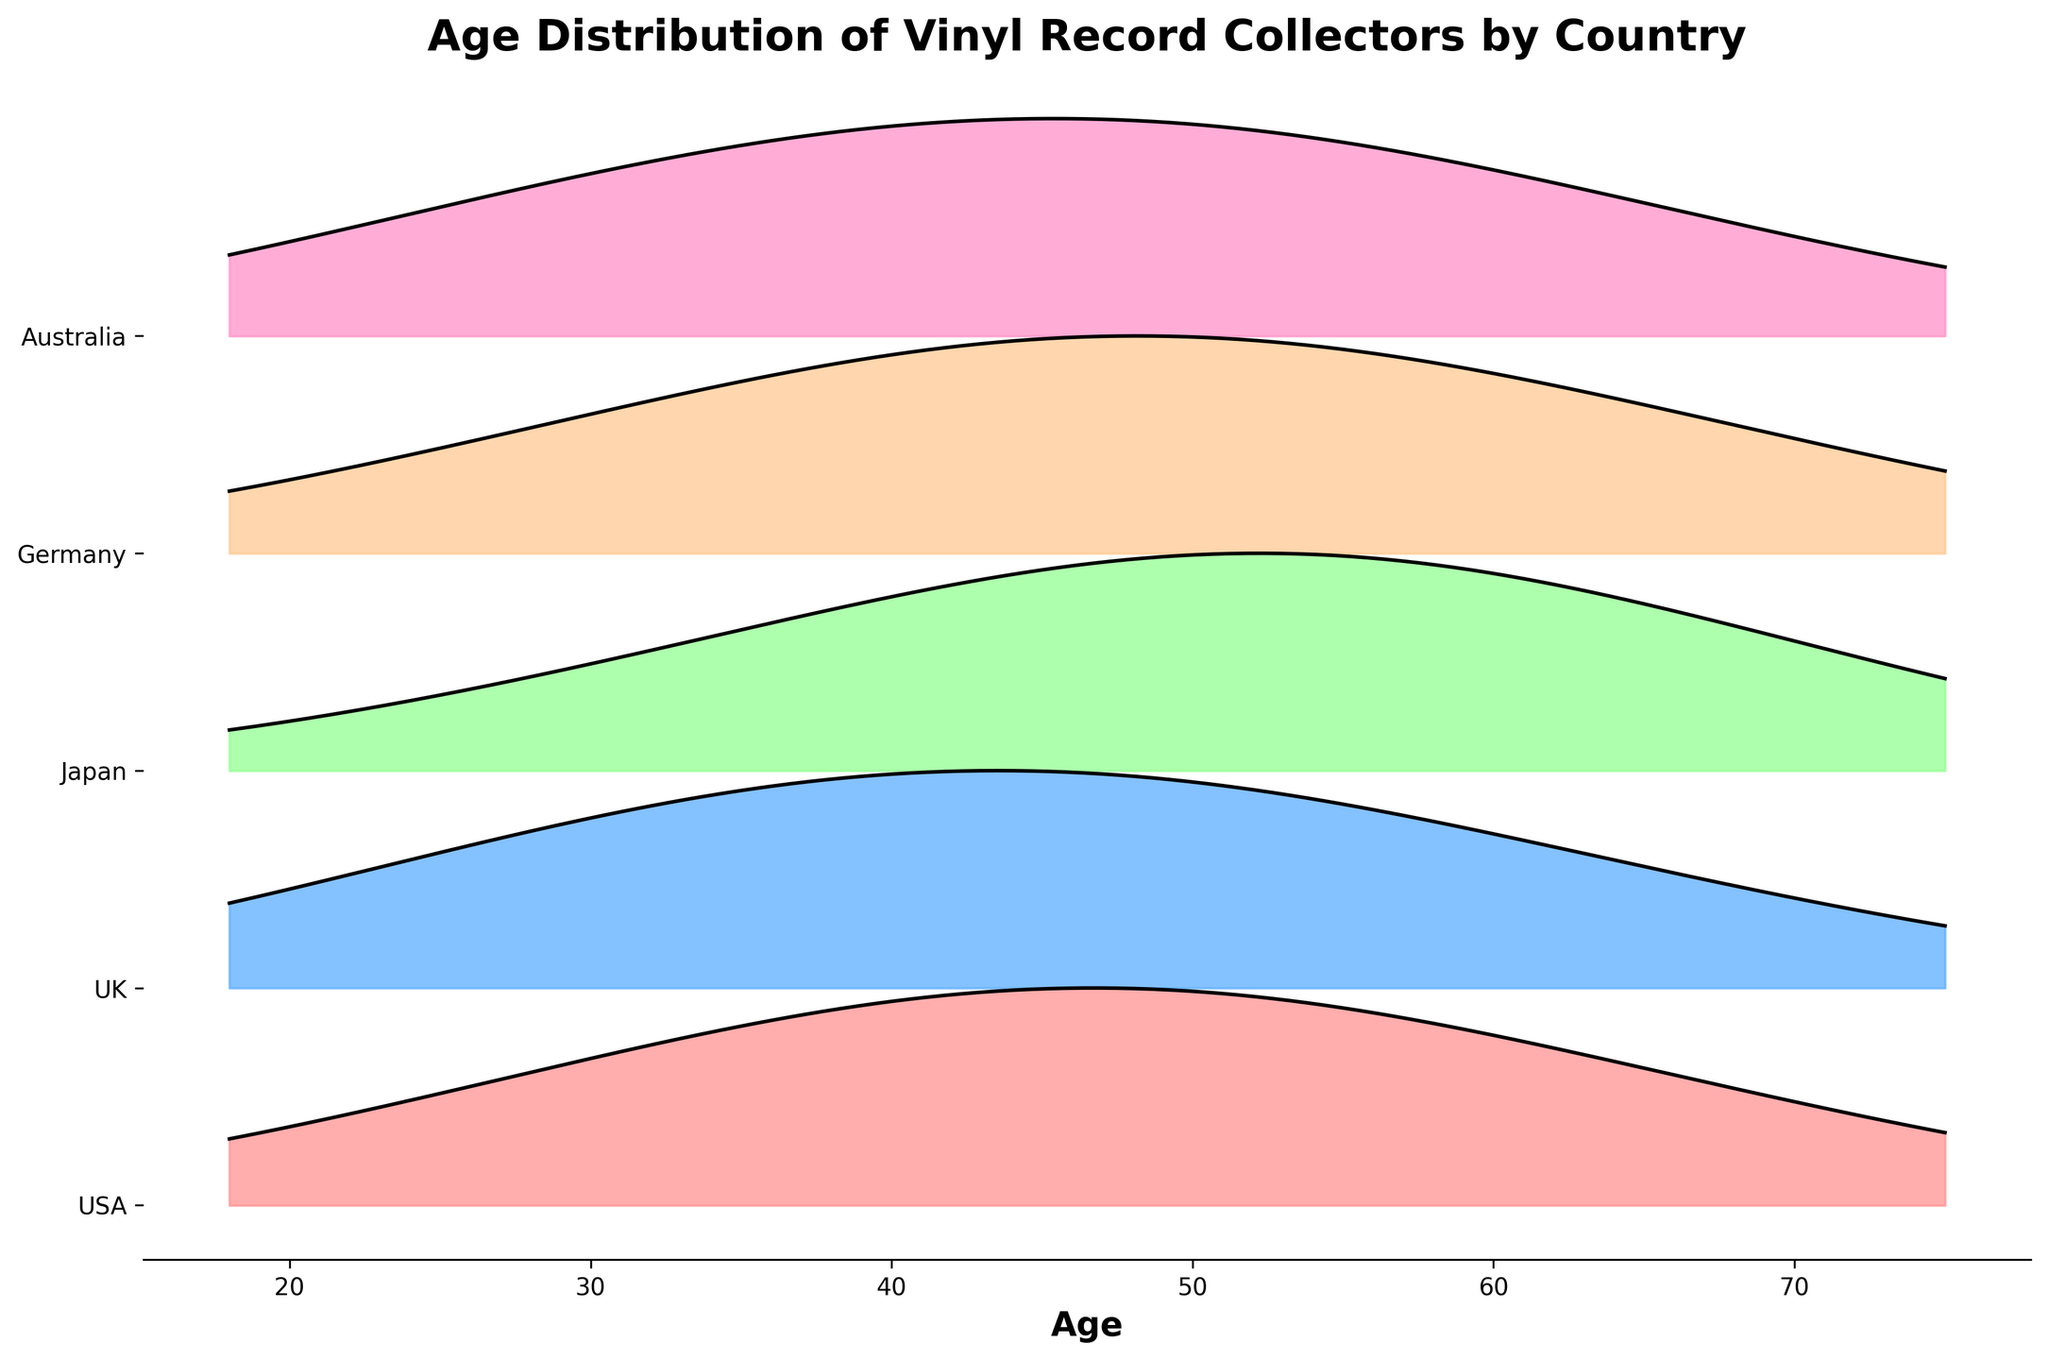How many countries are represented in the plot? The y-axis labels indicate the number of distinct countries, one for each ridgeline in the plot. There are 5 countries: USA, UK, Japan, Germany, and Australia.
Answer: 5 Which country shows the highest density of vinyl record collectors in the 55-year-old age range? Checking each specific ridgeline, the USA has a density of 0.18, the UK has 0.16, Japan has 0.25, Germany has 0.19, and Australia has 0.17 for the 55-year-old age group. Japan has the highest density.
Answer: Japan Comparing the density of vinyl record collectors around the 25-year-old age range, which country has the lowest density? Observing the densities for each country in the 25-year-old age group: USA (0.08), UK (0.10), Japan (0.05), Germany (0.07), and Australia (0.09), Japan has the lowest density at 0.05.
Answer: Japan What is the main trend observed in vinyl record collector densities across different age groups? Examining the general shape of ridgelines, most countries show a trend where density increases up to middle age (around 45-55 years) and then decreases in older age groups.
Answer: Increase then decrease At what age does the USA have its peak density for vinyl record collectors according to the plot? Looking at the USA ridgeline, the peak density is at the 45-year-old mark where it reaches 0.22.
Answer: 45 Which two countries have the closest density values in the 65-year-old age range? Comparing the densities at the 65-year-old range: USA (0.10), UK (0.08), Japan (0.15), Germany (0.11), and Australia (0.09), the UK and Australia have the closest densities of 0.08 and 0.09 respectively.
Answer: UK and Australia Is the density distribution of vinyl record collectors more dispersed in Germany or Australia? By comparing the widths of the ridgelines, it seems Germany's ridgeline is wider, indicating a more dispersed distribution compared to Australia's.
Answer: Germany If you sum the peak density values observed for each country, what is the total? USA: 0.22, UK: 0.20, Japan: 0.25, Germany: 0.21, Australia: 0.19; summing these values: 0.22 + 0.20 + 0.25 + 0.21 + 0.19 = 1.07.
Answer: 1.07 What common characteristic is observed in the densities of the oldest age group (75 years) across all countries? Observing the ridgelines for the 75-year-old age group, they all have relatively lower densities compared to younger age groups, indicating fewer collectors in this age range.
Answer: Low densities 